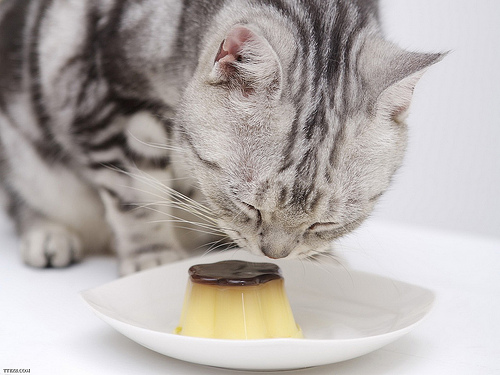Please provide the bounding box coordinate of the region this sentence describes: cat's tail curled around it's leg. The cat's fluffy tail gently wraps around its leg, and this endearing detail is framed by the coordinates [0.0, 0.35, 0.24, 0.63]. 